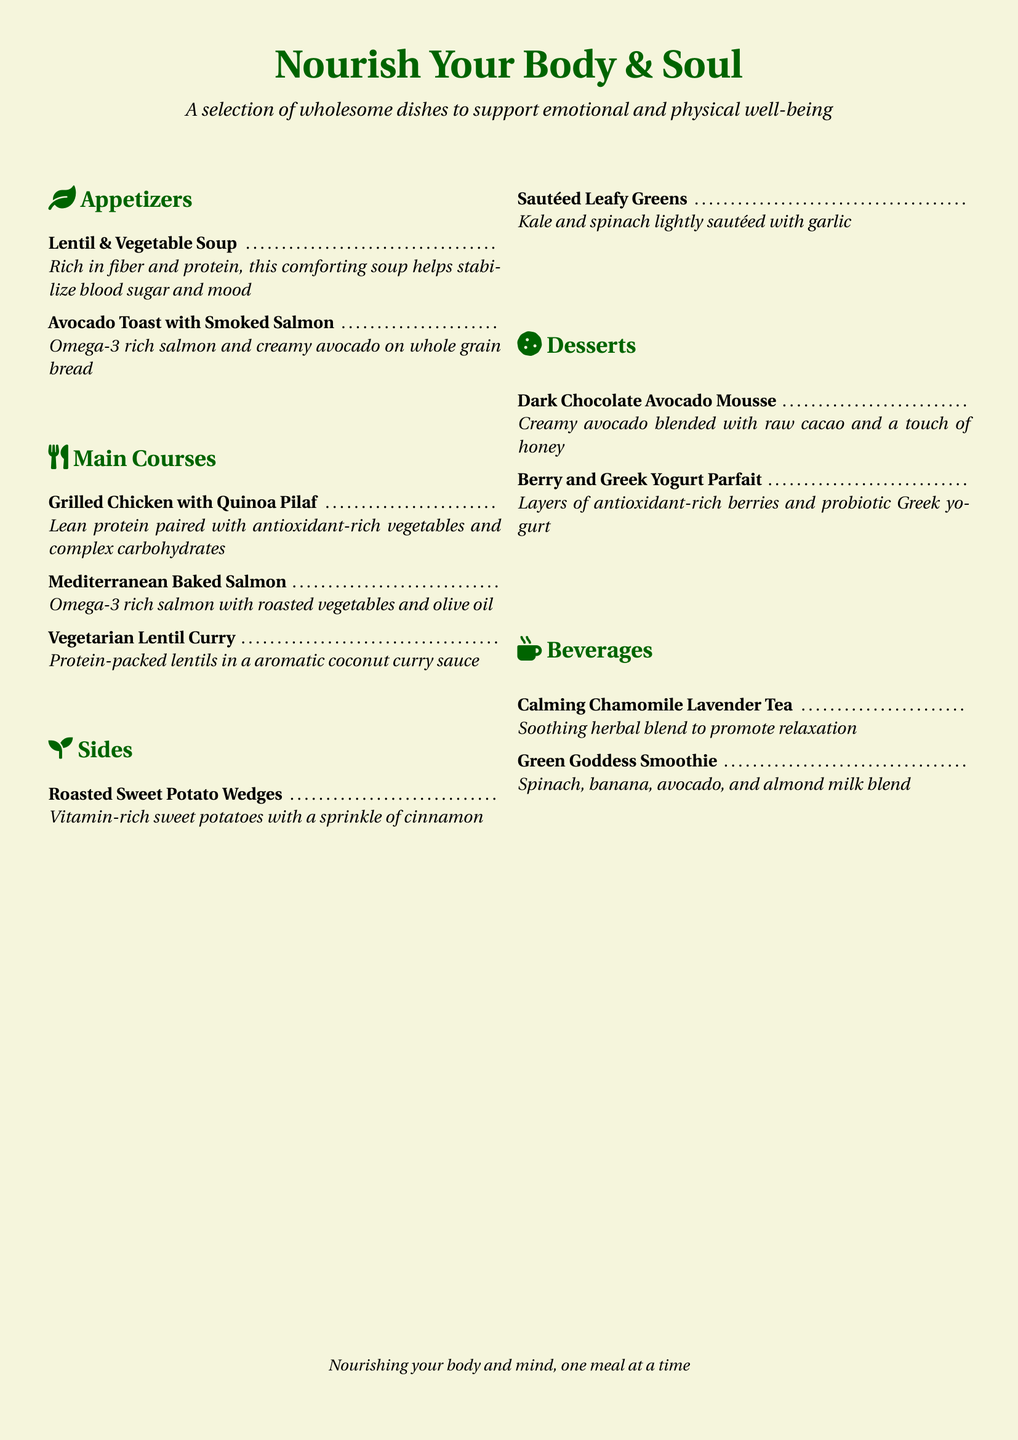What is the title of the menu? The title of the menu is prominently displayed at the top of the document, which is "Nourish Your Body & Soul".
Answer: Nourish Your Body & Soul How many appetizers are listed in the menu? The menu lists a total of two appetizers in the appetizers section.
Answer: 2 What is one benefit of the Lentil & Vegetable Soup? The document specifies that the soup helps stabilize blood sugar and mood.
Answer: Stabilize blood sugar and mood Which beverage promotes relaxation? The menu highlights the "Calming Chamomile Lavender Tea" as a soothing herbal blend to promote relaxation.
Answer: Calming Chamomile Lavender Tea What protein source is used in the Mediterranean Baked Salmon dish? The dish uses salmon as the primary protein source, which is rich in Omega-3.
Answer: Salmon What is common between the Dark Chocolate Avocado Mousse and the Berry and Greek Yogurt Parfait? Both desserts provide nutritional benefits, being rich in antioxidants and healthy fats.
Answer: Nutritional benefits How many main courses are offered on the menu? There are three main courses listed in the main courses section of the menu.
Answer: 3 What ingredient is featured in the Green Goddess Smoothie? The Green Goddess Smoothie includes spinach as one of its main ingredients.
Answer: Spinach 